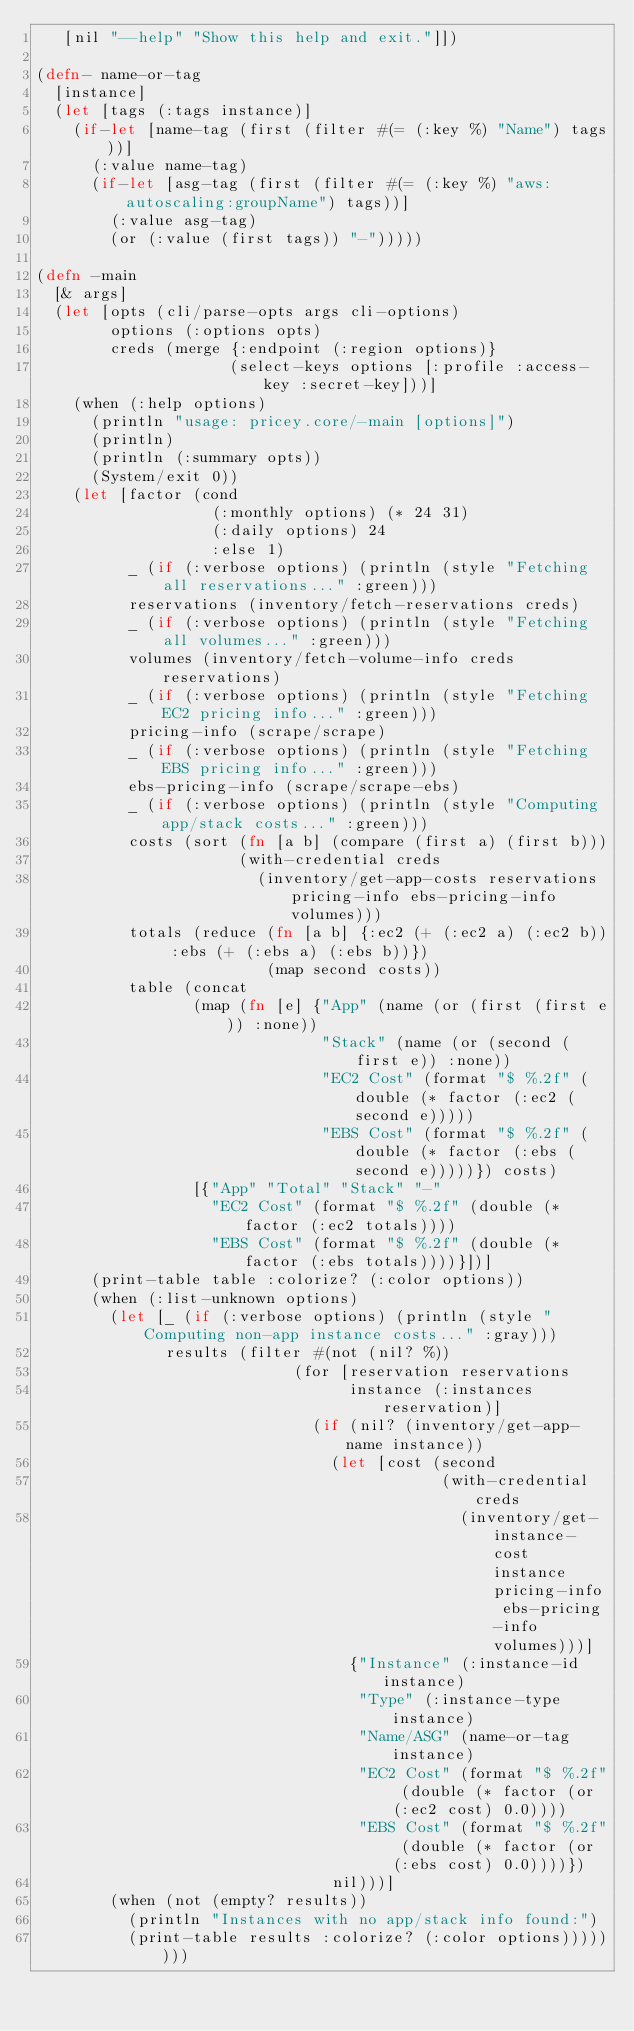<code> <loc_0><loc_0><loc_500><loc_500><_Clojure_>   [nil "--help" "Show this help and exit."]])

(defn- name-or-tag
  [instance]
  (let [tags (:tags instance)]
    (if-let [name-tag (first (filter #(= (:key %) "Name") tags))]
      (:value name-tag)
      (if-let [asg-tag (first (filter #(= (:key %) "aws:autoscaling:groupName") tags))]
        (:value asg-tag)
        (or (:value (first tags)) "-")))))

(defn -main
  [& args]
  (let [opts (cli/parse-opts args cli-options)
        options (:options opts)
        creds (merge {:endpoint (:region options)}
                     (select-keys options [:profile :access-key :secret-key]))]
    (when (:help options)
      (println "usage: pricey.core/-main [options]")
      (println)
      (println (:summary opts))
      (System/exit 0))
    (let [factor (cond
                   (:monthly options) (* 24 31)
                   (:daily options) 24
                   :else 1)
          _ (if (:verbose options) (println (style "Fetching all reservations..." :green)))
          reservations (inventory/fetch-reservations creds)
          _ (if (:verbose options) (println (style "Fetching all volumes..." :green)))
          volumes (inventory/fetch-volume-info creds reservations)
          _ (if (:verbose options) (println (style "Fetching EC2 pricing info..." :green)))
          pricing-info (scrape/scrape)
          _ (if (:verbose options) (println (style "Fetching EBS pricing info..." :green)))
          ebs-pricing-info (scrape/scrape-ebs)
          _ (if (:verbose options) (println (style "Computing app/stack costs..." :green)))
          costs (sort (fn [a b] (compare (first a) (first b)))
                      (with-credential creds
                        (inventory/get-app-costs reservations pricing-info ebs-pricing-info volumes)))
          totals (reduce (fn [a b] {:ec2 (+ (:ec2 a) (:ec2 b)) :ebs (+ (:ebs a) (:ebs b))})
                         (map second costs))
          table (concat
                 (map (fn [e] {"App" (name (or (first (first e)) :none))
                               "Stack" (name (or (second (first e)) :none))
                               "EC2 Cost" (format "$ %.2f" (double (* factor (:ec2 (second e)))))
                               "EBS Cost" (format "$ %.2f" (double (* factor (:ebs (second e)))))}) costs)
                 [{"App" "Total" "Stack" "-"
                   "EC2 Cost" (format "$ %.2f" (double (* factor (:ec2 totals))))
                   "EBS Cost" (format "$ %.2f" (double (* factor (:ebs totals))))}])]
      (print-table table :colorize? (:color options))
      (when (:list-unknown options)
        (let [_ (if (:verbose options) (println (style "Computing non-app instance costs..." :gray)))
              results (filter #(not (nil? %))
                            (for [reservation reservations
                                  instance (:instances reservation)]
                              (if (nil? (inventory/get-app-name instance))
                                (let [cost (second
                                            (with-credential creds
                                              (inventory/get-instance-cost instance pricing-info ebs-pricing-info volumes)))]
                                  {"Instance" (:instance-id instance)
                                   "Type" (:instance-type instance)
                                   "Name/ASG" (name-or-tag instance)
                                   "EC2 Cost" (format "$ %.2f" (double (* factor (or (:ec2 cost) 0.0))))
                                   "EBS Cost" (format "$ %.2f" (double (* factor (or (:ebs cost) 0.0))))})
                                nil)))]
        (when (not (empty? results))
          (println "Instances with no app/stack info found:")
          (print-table results :colorize? (:color options))))))))
</code> 